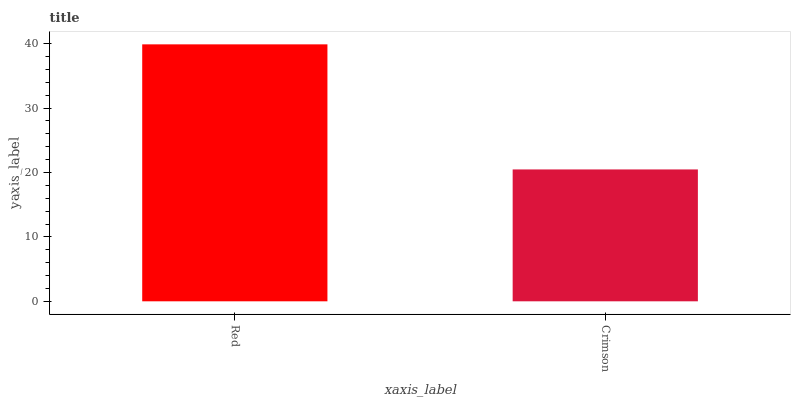Is Crimson the minimum?
Answer yes or no. Yes. Is Red the maximum?
Answer yes or no. Yes. Is Crimson the maximum?
Answer yes or no. No. Is Red greater than Crimson?
Answer yes or no. Yes. Is Crimson less than Red?
Answer yes or no. Yes. Is Crimson greater than Red?
Answer yes or no. No. Is Red less than Crimson?
Answer yes or no. No. Is Red the high median?
Answer yes or no. Yes. Is Crimson the low median?
Answer yes or no. Yes. Is Crimson the high median?
Answer yes or no. No. Is Red the low median?
Answer yes or no. No. 